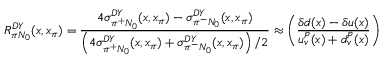Convert formula to latex. <formula><loc_0><loc_0><loc_500><loc_500>R _ { \pi N _ { 0 } } ^ { D Y } ( x , x _ { \pi } ) = \frac { 4 \sigma _ { \pi ^ { + } N _ { 0 } } ^ { D Y } ( x , x _ { \pi } ) - \sigma _ { \pi ^ { - } N _ { 0 } } ^ { D Y } ( x , x _ { \pi } ) } { \left ( 4 \sigma _ { \pi ^ { + } N _ { 0 } } ^ { D Y } ( x , x _ { \pi } ) + \sigma _ { \pi ^ { - } N _ { 0 } } ^ { D Y } ( x , x _ { \pi } ) \right ) / 2 } \approx \left ( \frac { \delta d ( x ) - \delta u ( x ) } { u _ { v } ^ { p } ( x ) + d _ { v } ^ { p } ( x ) } \right )</formula> 